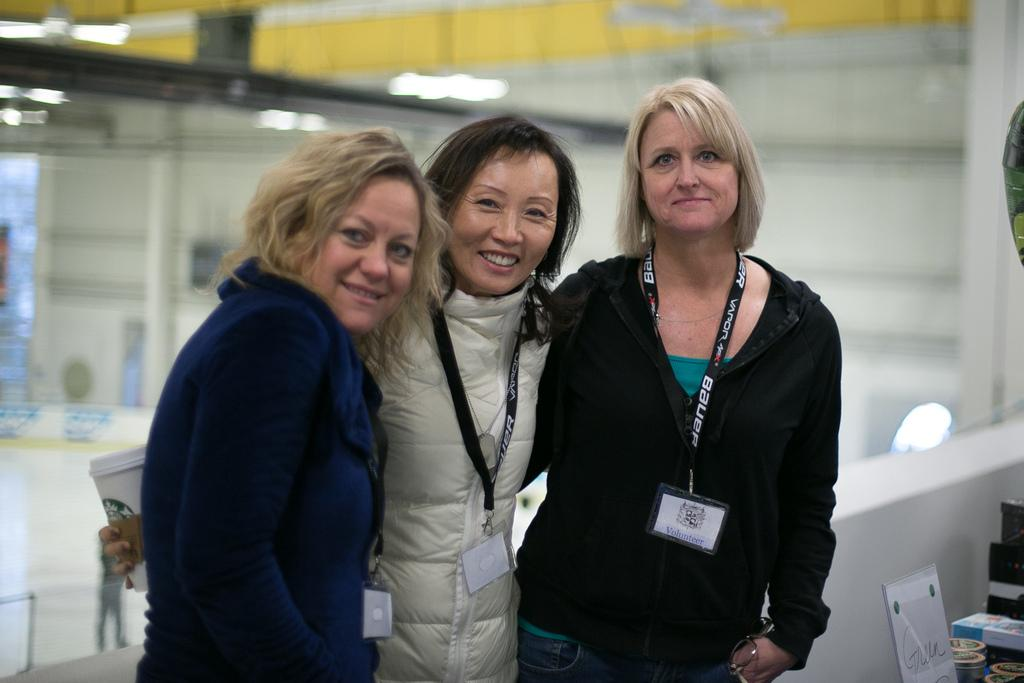How many people are in the image? There are three persons standing in the image. What is one person holding in the image? One person is holding a cup. What can be seen in the right side corner of the image? There are objects on the right side corner of the image. Can you describe the background of the image? The background of the image is blurred. What type of smile can be seen on the carpenter's face in the image? There is no carpenter present in the image, and therefore no smile to observe. 